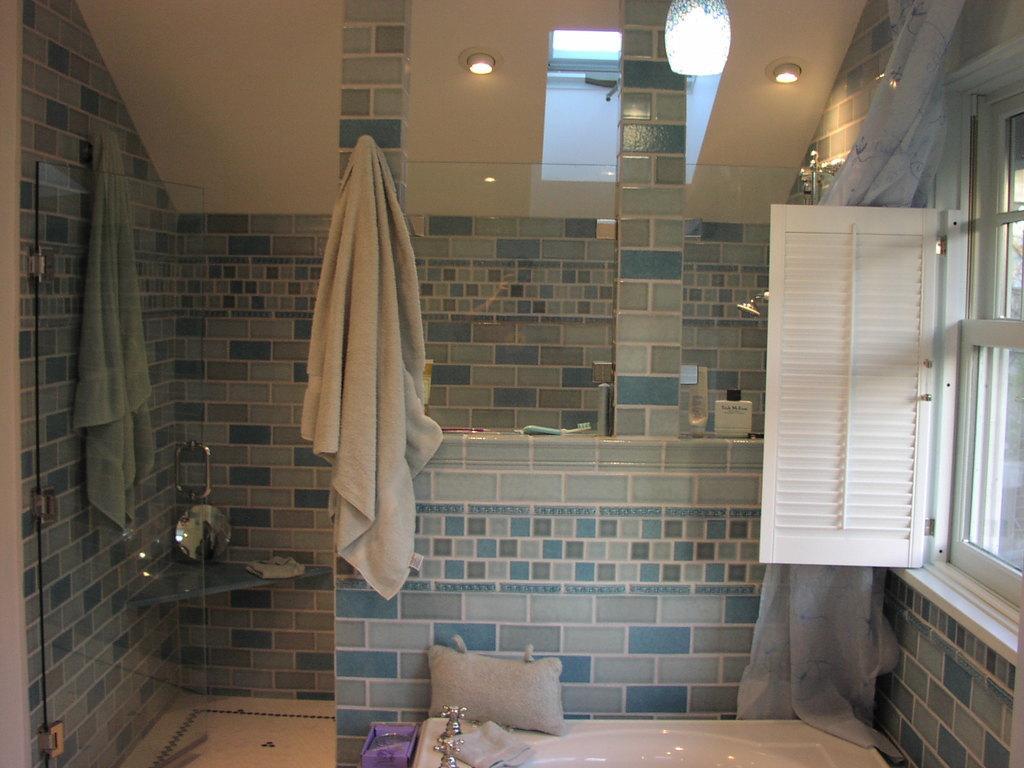How would you summarize this image in a sentence or two? This is a picture of a washroom. On the right there are window, door, curtain, shower and lights. In the center of the picture there are towel, bathtub, taps, brush, shampoo and lights. On the left there are curtain, door and towel. 